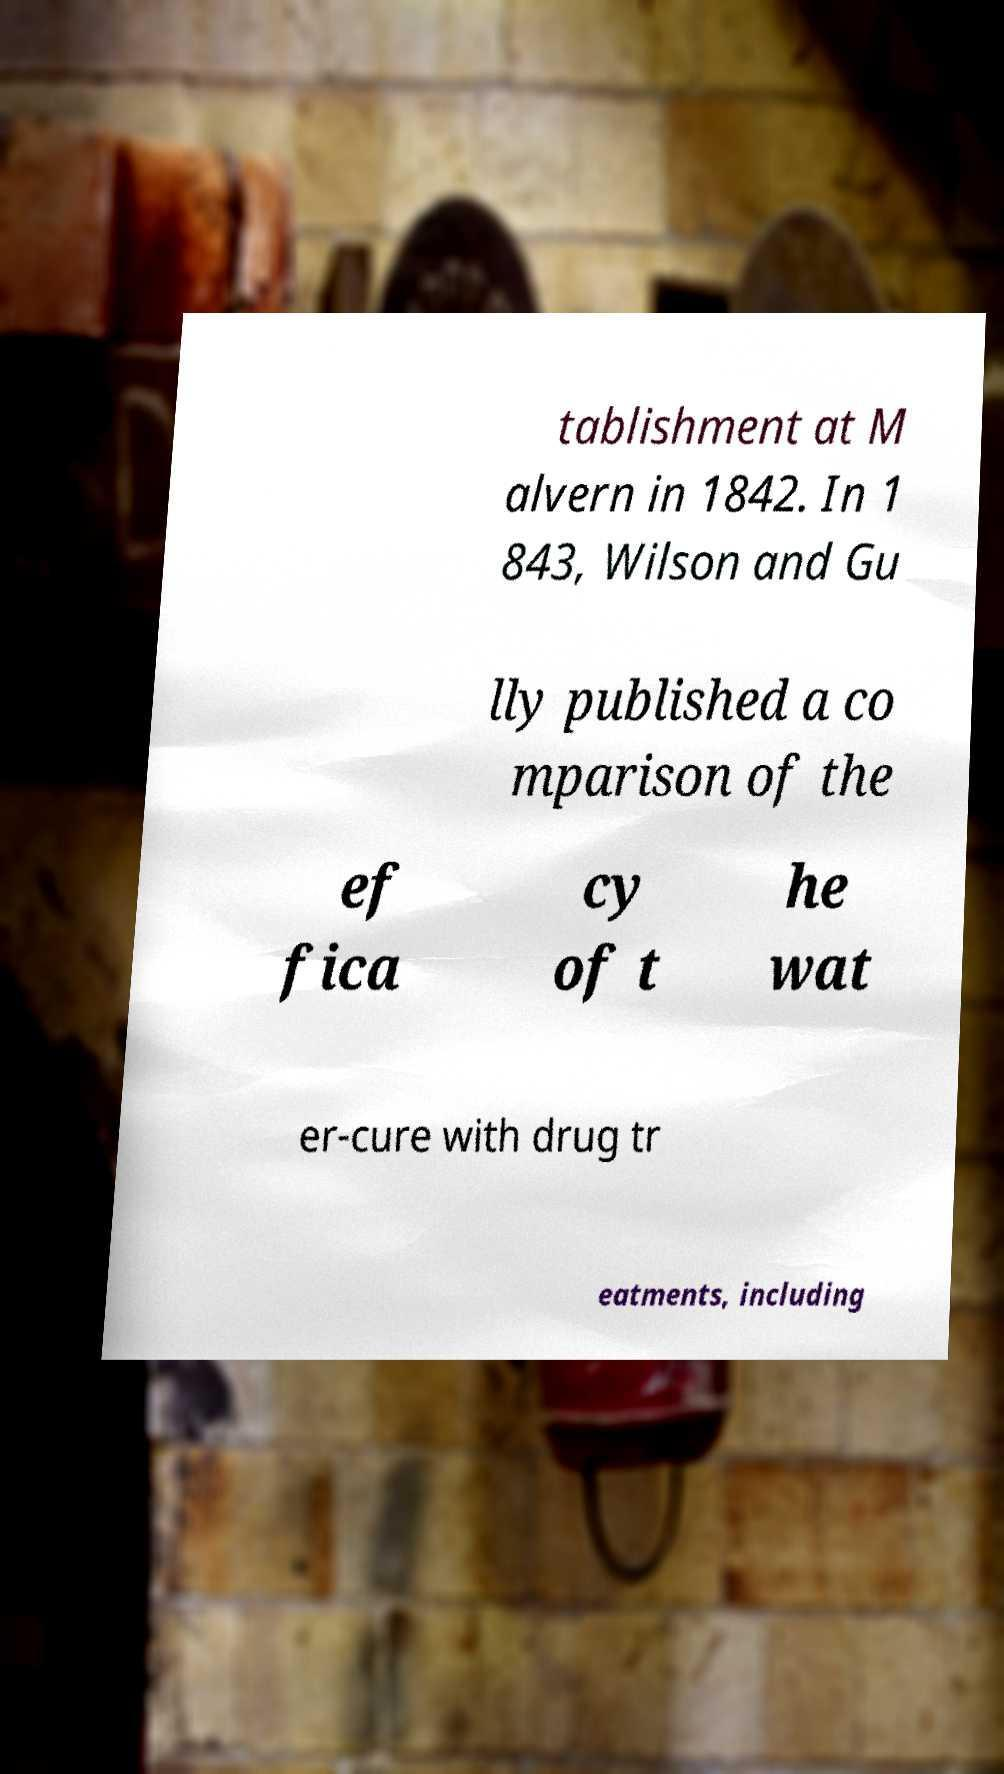Could you assist in decoding the text presented in this image and type it out clearly? tablishment at M alvern in 1842. In 1 843, Wilson and Gu lly published a co mparison of the ef fica cy of t he wat er-cure with drug tr eatments, including 